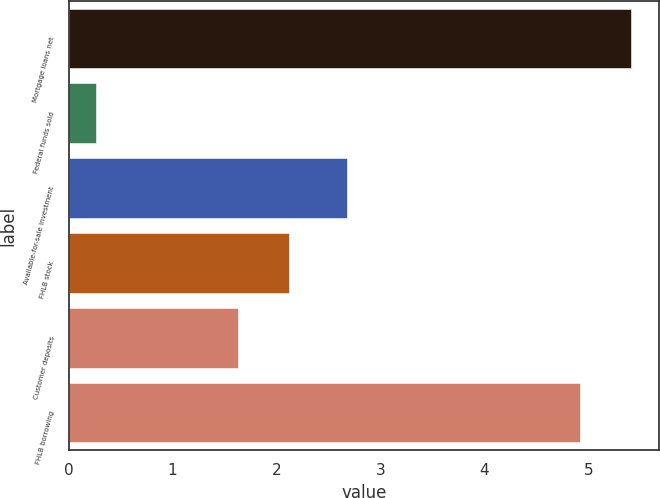Convert chart. <chart><loc_0><loc_0><loc_500><loc_500><bar_chart><fcel>Mortgage loans net<fcel>Federal funds sold<fcel>Available-for-sale investment<fcel>FHLB stock<fcel>Customer deposits<fcel>FHLB borrowing<nl><fcel>5.41<fcel>0.26<fcel>2.68<fcel>2.12<fcel>1.63<fcel>4.92<nl></chart> 